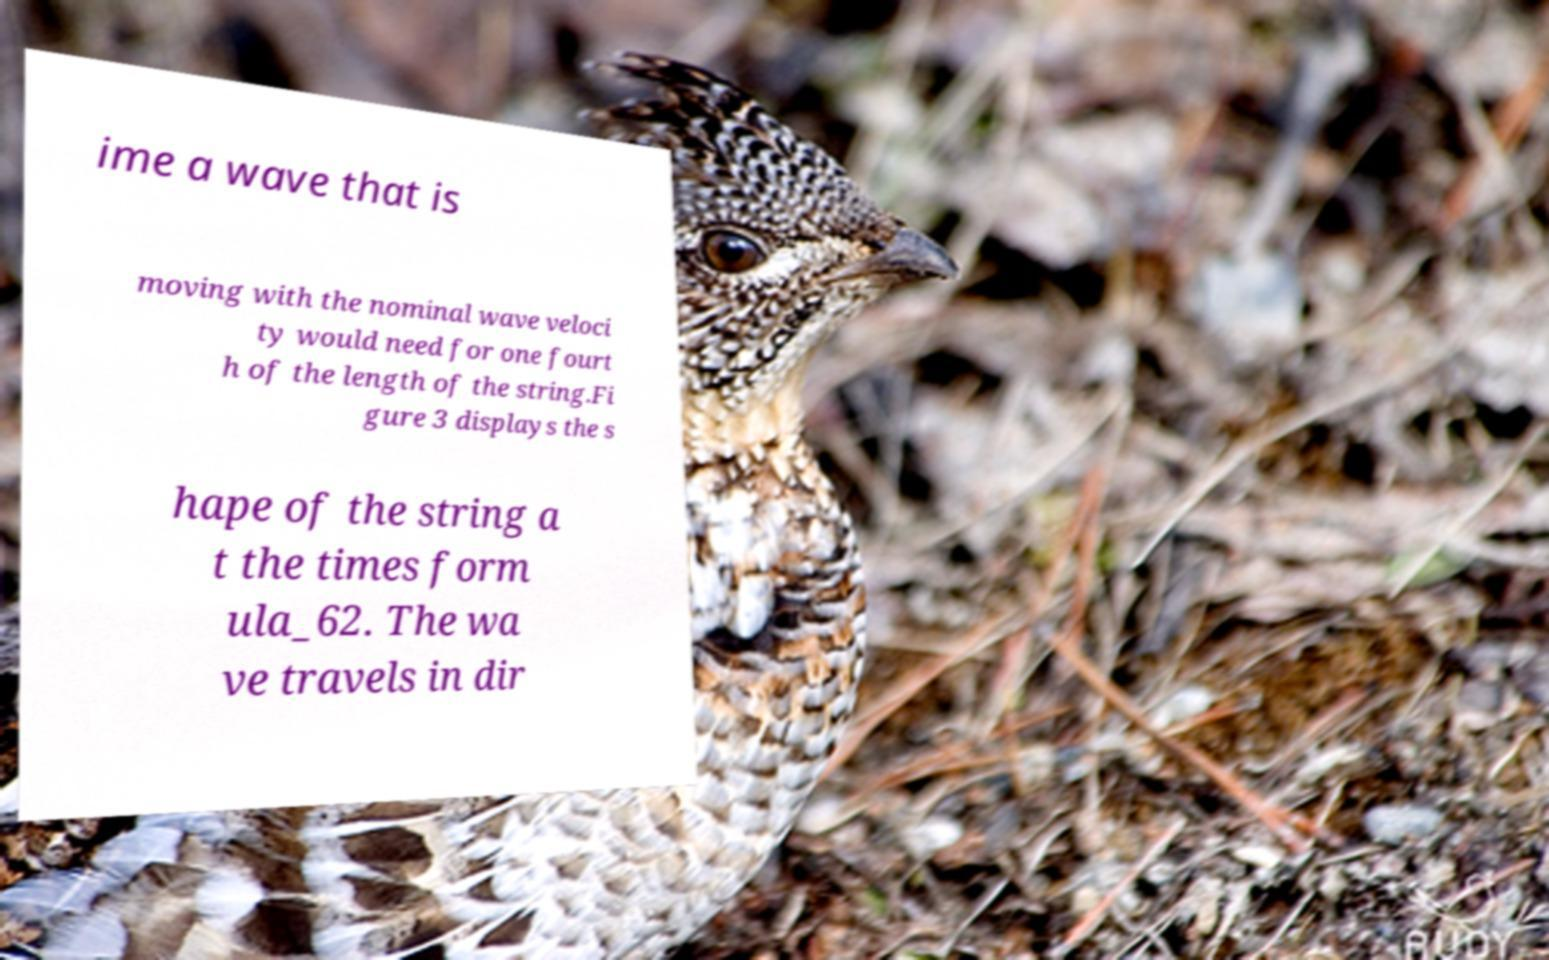What messages or text are displayed in this image? I need them in a readable, typed format. ime a wave that is moving with the nominal wave veloci ty would need for one fourt h of the length of the string.Fi gure 3 displays the s hape of the string a t the times form ula_62. The wa ve travels in dir 